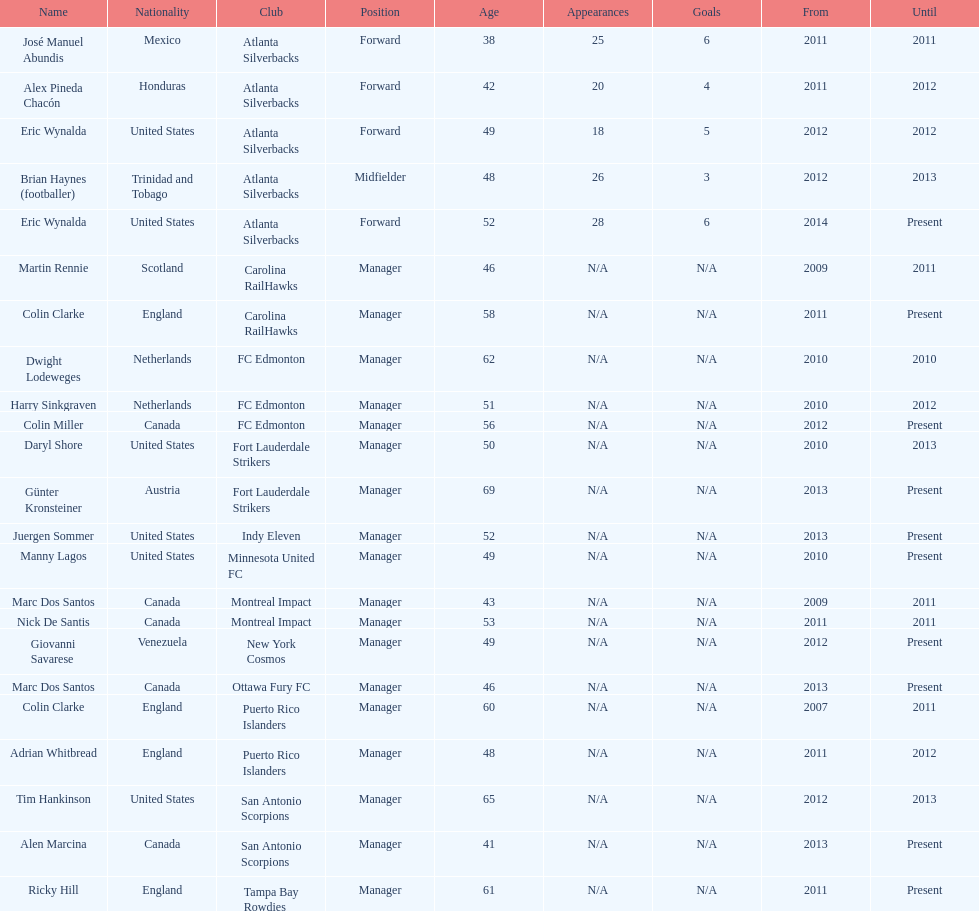Prior to miller, who served as the head coach for fc edmonton? Harry Sinkgraven. 